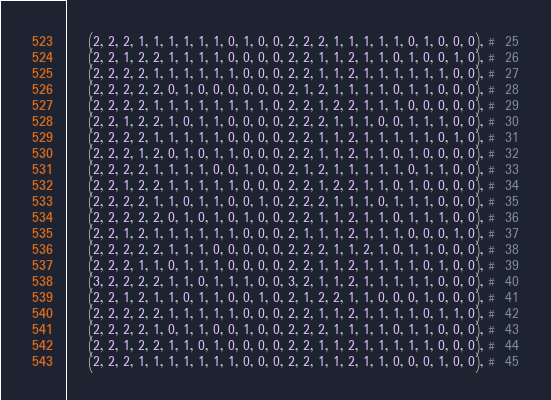Convert code to text. <code><loc_0><loc_0><loc_500><loc_500><_Python_>	(2, 2, 2, 1, 1, 1, 1, 1, 1, 0, 1, 0, 0, 2, 2, 2, 1, 1, 1, 1, 1, 0, 1, 0, 0, 0), #  25
	(2, 2, 1, 2, 2, 1, 1, 1, 1, 0, 0, 0, 0, 2, 2, 1, 1, 2, 1, 1, 0, 1, 0, 0, 1, 0), #  26
	(2, 2, 2, 2, 1, 1, 1, 1, 1, 1, 0, 0, 0, 2, 2, 1, 1, 2, 1, 1, 1, 1, 1, 1, 0, 0), #  27
	(2, 2, 2, 2, 2, 0, 1, 0, 0, 0, 0, 0, 0, 2, 1, 2, 1, 1, 1, 1, 0, 1, 1, 0, 0, 0), #  28
	(2, 2, 2, 2, 1, 1, 1, 1, 1, 1, 1, 1, 0, 2, 2, 1, 2, 2, 1, 1, 1, 0, 0, 0, 0, 0), #  29
	(2, 2, 1, 2, 2, 1, 0, 1, 1, 0, 0, 0, 0, 2, 2, 2, 1, 1, 1, 0, 0, 1, 1, 1, 0, 0), #  30
	(2, 2, 2, 2, 1, 1, 1, 1, 1, 0, 0, 0, 0, 2, 2, 1, 1, 2, 1, 1, 1, 1, 1, 0, 1, 0), #  31
	(2, 2, 2, 1, 2, 0, 1, 0, 1, 1, 0, 0, 0, 2, 2, 1, 1, 2, 1, 1, 0, 1, 0, 0, 0, 0), #  32
	(2, 2, 2, 2, 1, 1, 1, 1, 0, 0, 1, 0, 0, 2, 1, 2, 1, 1, 1, 1, 1, 0, 1, 1, 0, 0), #  33
	(2, 2, 1, 2, 2, 1, 1, 1, 1, 1, 0, 0, 0, 2, 2, 1, 2, 2, 1, 1, 0, 1, 0, 0, 0, 0), #  34
	(2, 2, 2, 2, 1, 1, 0, 1, 1, 0, 0, 1, 0, 2, 2, 2, 1, 1, 1, 0, 1, 1, 1, 0, 0, 0), #  35
	(2, 2, 2, 2, 2, 0, 1, 0, 1, 0, 1, 0, 0, 2, 2, 1, 1, 2, 1, 1, 0, 1, 1, 1, 0, 0), #  36
	(2, 2, 1, 2, 1, 1, 1, 1, 1, 1, 0, 0, 0, 2, 1, 1, 1, 2, 1, 1, 1, 0, 0, 0, 1, 0), #  37
	(2, 2, 2, 2, 2, 1, 1, 1, 0, 0, 0, 0, 0, 2, 2, 2, 1, 1, 2, 1, 0, 1, 1, 0, 0, 0), #  38
	(2, 2, 2, 1, 1, 0, 1, 1, 1, 0, 0, 0, 0, 2, 2, 1, 1, 2, 1, 1, 1, 1, 0, 1, 0, 0), #  39
	(3, 2, 2, 2, 2, 1, 1, 0, 1, 1, 1, 0, 0, 3, 2, 1, 1, 2, 1, 1, 1, 1, 1, 0, 0, 0), #  40
	(2, 2, 1, 2, 1, 1, 0, 1, 1, 0, 0, 1, 0, 2, 1, 2, 2, 1, 1, 0, 0, 0, 1, 0, 0, 0), #  41
	(2, 2, 2, 2, 2, 1, 1, 1, 1, 1, 0, 0, 0, 2, 2, 1, 1, 2, 1, 1, 1, 1, 0, 1, 1, 0), #  42
	(2, 2, 2, 2, 1, 0, 1, 1, 0, 0, 1, 0, 0, 2, 2, 2, 1, 1, 1, 1, 0, 1, 1, 0, 0, 0), #  43
	(2, 2, 1, 2, 2, 1, 1, 0, 1, 0, 0, 0, 0, 2, 2, 1, 1, 2, 1, 1, 1, 1, 1, 0, 0, 0), #  44
	(2, 2, 2, 1, 1, 1, 1, 1, 1, 1, 0, 0, 0, 2, 2, 1, 1, 2, 1, 1, 0, 0, 0, 1, 0, 0), #  45</code> 